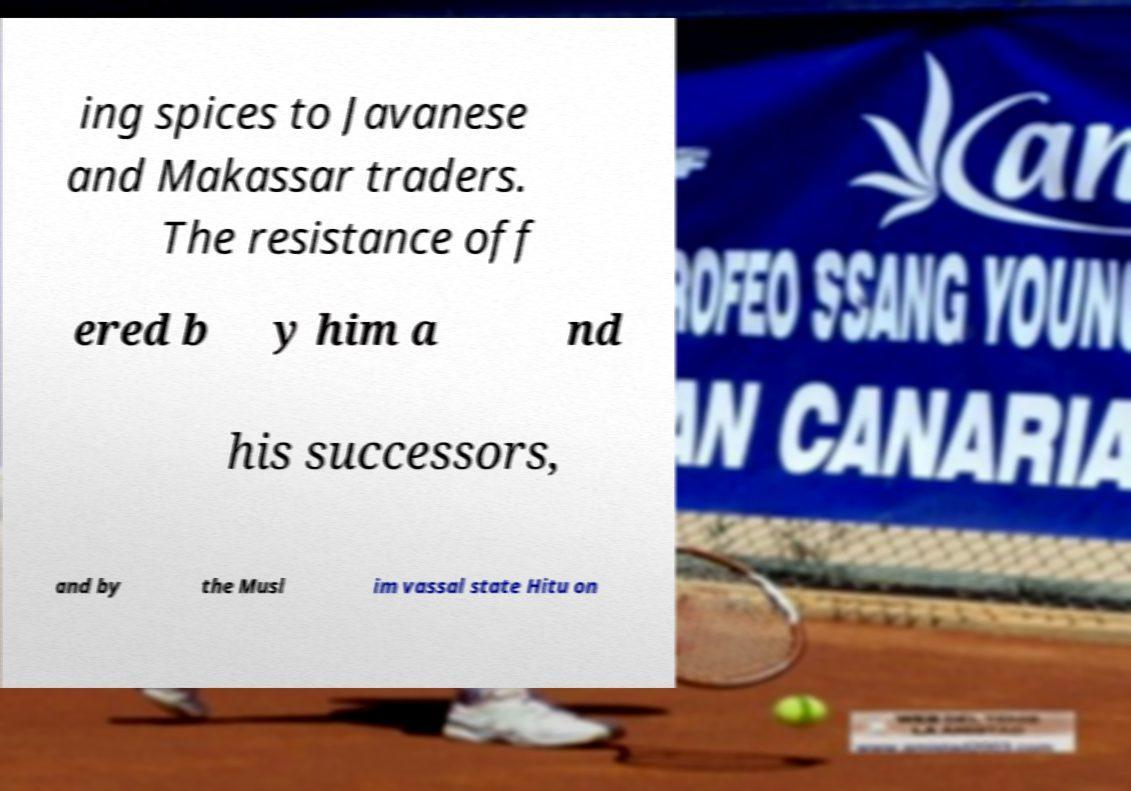Can you read and provide the text displayed in the image?This photo seems to have some interesting text. Can you extract and type it out for me? ing spices to Javanese and Makassar traders. The resistance off ered b y him a nd his successors, and by the Musl im vassal state Hitu on 